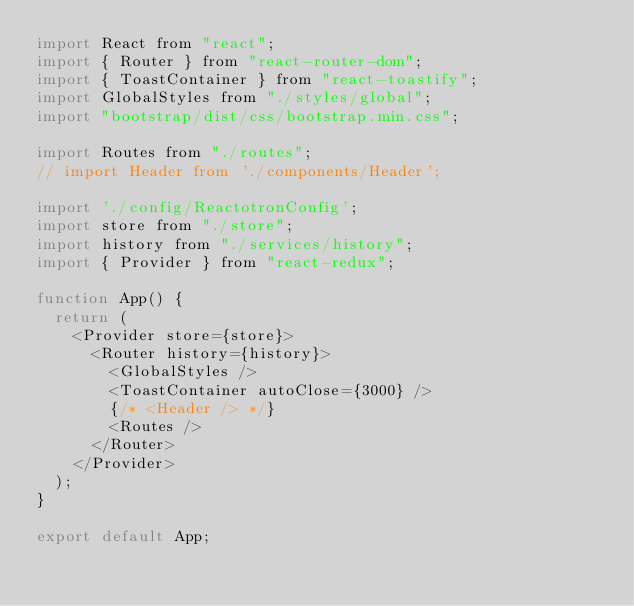<code> <loc_0><loc_0><loc_500><loc_500><_JavaScript_>import React from "react";
import { Router } from "react-router-dom";
import { ToastContainer } from "react-toastify";
import GlobalStyles from "./styles/global";
import "bootstrap/dist/css/bootstrap.min.css";

import Routes from "./routes";
// import Header from './components/Header';

import './config/ReactotronConfig';
import store from "./store";
import history from "./services/history";
import { Provider } from "react-redux";

function App() {
  return (
    <Provider store={store}>
      <Router history={history}>
        <GlobalStyles />
        <ToastContainer autoClose={3000} />
        {/* <Header /> */}
        <Routes />
      </Router>
    </Provider>
  );
}

export default App;
</code> 